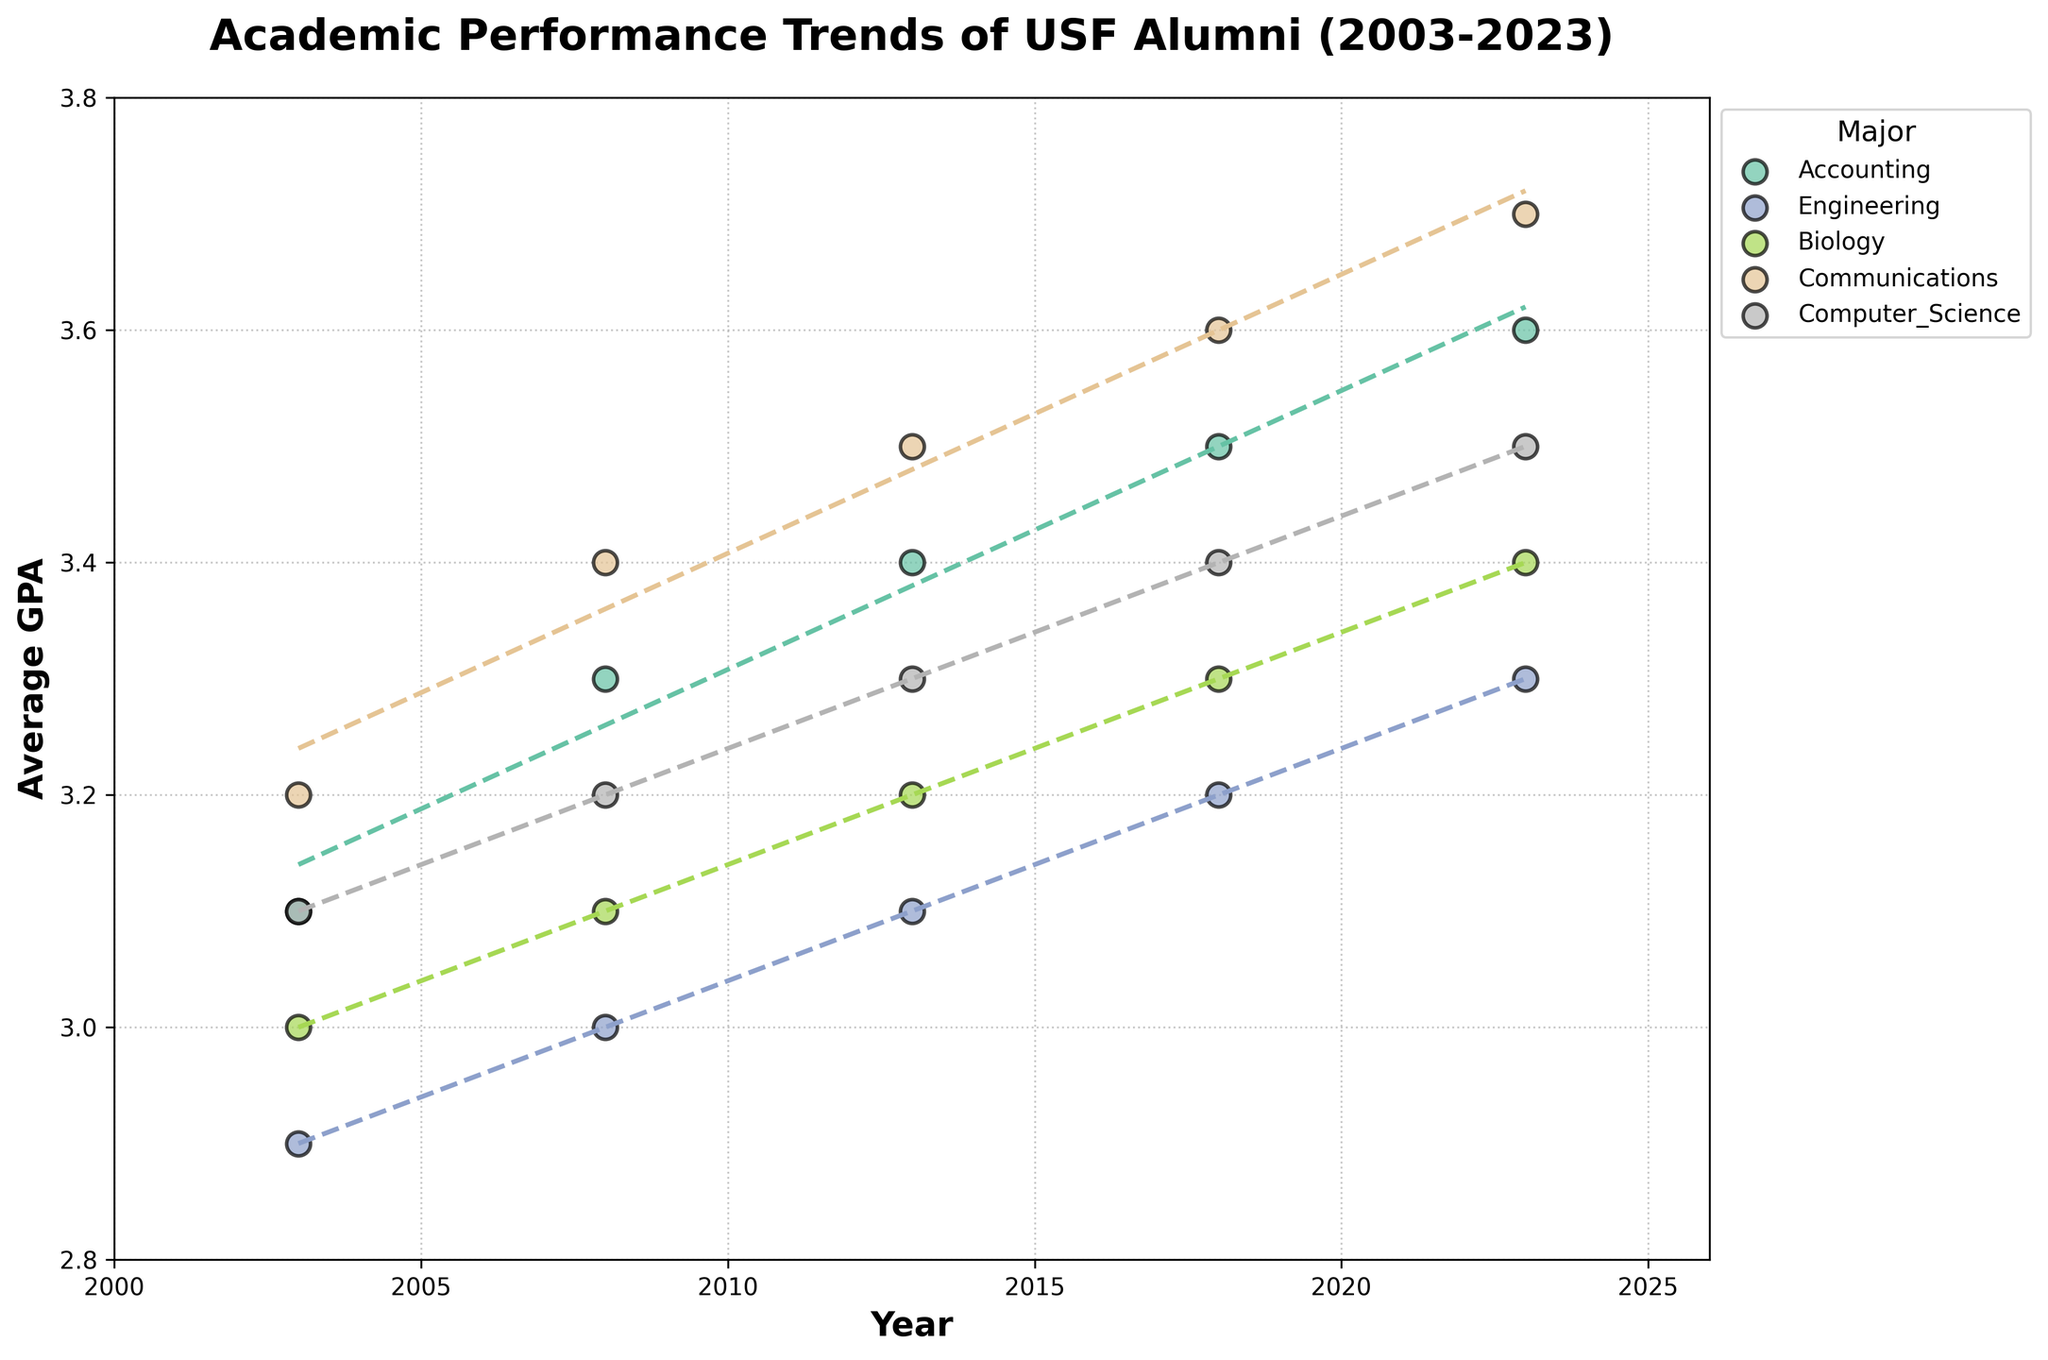How does the GPA trend for Computer Science majors change over the 20-year period? Observe that the scatter points and trend line for Computer Science show an upward slope. From 2003 to 2023, the GPAs improve from 3.1 to 3.5.
Answer: Upward trend Which major shows the most significant increase in GPA from 2003 to 2023? Compare the starting and ending GPAs of all majors. Communications has the greatest increase, going from 3.2 in 2003 to 3.7 in 2023, a total increase of 0.5.
Answer: Communications What is the average GPA for Accounting majors in the year 2018? Look at the scatter point on the graph corresponding to Accounting in 2018. The GPA for Accounting in 2018 is 3.5.
Answer: 3.5 Which major has the lowest GPA trend over the entire period? Compare the trend lines for all majors. Engineering consistently has the lowest trend line, starting at 2.9 and rising to 3.3 by 2023.
Answer: Engineering How does the GPA trend for Biology compare to Engineering? Observe both trend lines. Biology starts at 3.0 in 2003 and increases to 3.4 in 2023, whereas Engineering begins at 2.9 and reaches 3.3. Biology has a slightly higher starting and ending GPA.
Answer: Biology has a higher trend What is the difference in GPA between Communications and Computer Science in the year 2013? Find the scatter points for Communications and Computer Science in 2013. Communications is at 3.5 and Computer Science is at 3.3. The difference is 0.2.
Answer: 0.2 What is the GPA trend for Accounting majors over the 20 years? Observe the scatter points and trend line for Accounting. They show a consistent upward trend, from 3.1 in 2003 to 3.6 in 2023.
Answer: Upward trend In which year does Engineering reach a GPA of 3.0? Look at the scatter points for Engineering. The point representing 3.0 appears in the year 2008.
Answer: 2008 Which major has the highest GPA in the year 2023? Identify the highest scatter point in 2023. Communications has the highest GPA of 3.7 in that year.
Answer: Communications How does the GPA of Biology in 2003 compare to 2018? Observe the scatter points for Biology in 2003 and 2018. In 2003, it is 3.0, and in 2018, it is 3.3. The GPA increased by 0.3.
Answer: Increased by 0.3 